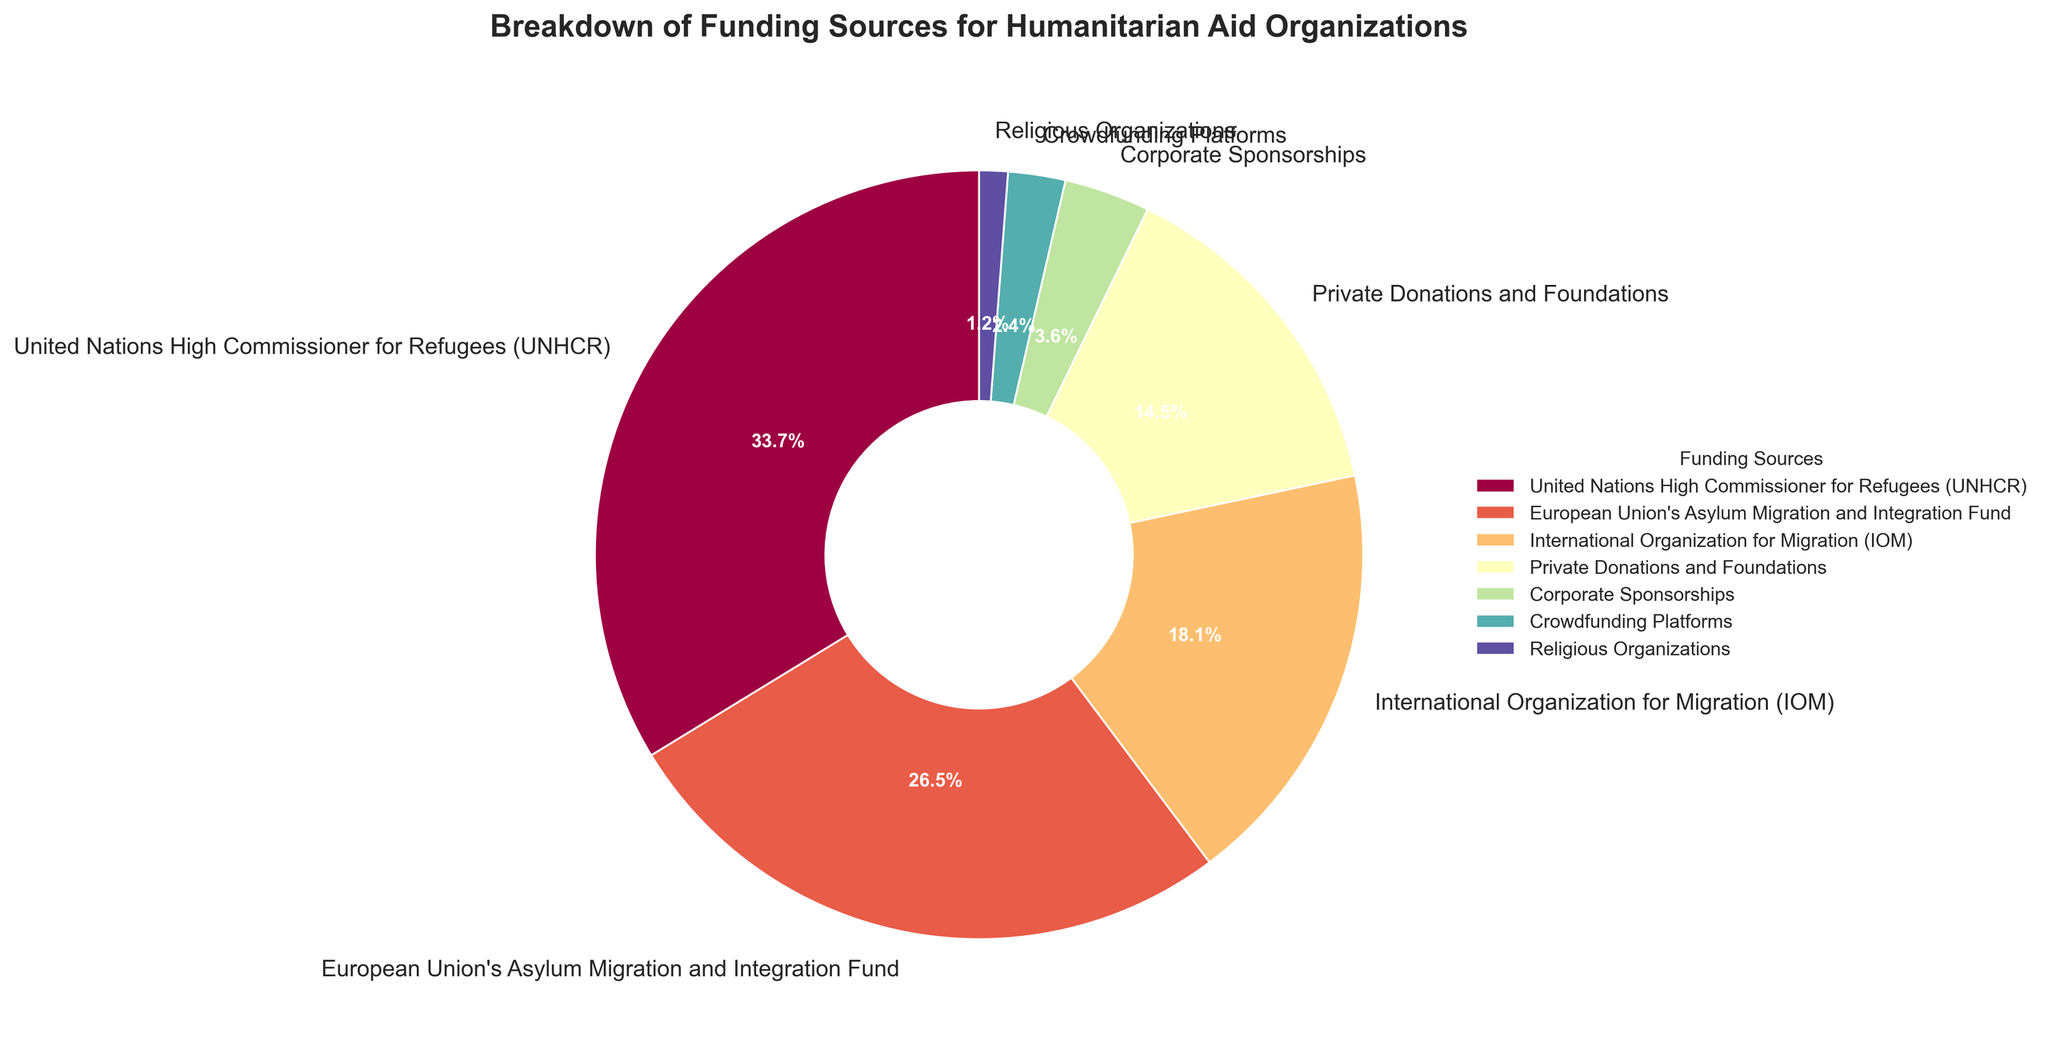Which funding source contributes the largest percentage? Look at the pie chart and identify the segment representing the largest portion. The UNHCR segment is the largest.
Answer: United Nations High Commissioner for Refugees (UNHCR) Which two funding sources together contribute more than 40% of the total funding? Identify pairs of segments in the pie chart whose combined percentages exceed 40%. The pairs of 'UNHCR' and 'European Union's Asylum Migration and Integration Fund' contribute a combined total of 28% + 22% = 50%.
Answer: United Nations High Commissioner for Refugees (UNHCR) and European Union's Asylum Migration and Integration Fund How much larger is the contribution of corporate sponsorships compared to crowdfunding platforms? Check the pie chart for the percentages of corporate sponsorships and crowdfunding platforms. Subtract the smaller percentage from the larger one: 3% - 2% = 1%.
Answer: 1% Which funding source contributes the smallest percentage? Identify the smallest segment in the pie chart. The smallest segment is labeled as 'Religious Organizations.'
Answer: Religious Organizations What is the total contribution percentage of private donations, corporate sponsorships, and religious organizations? Add the percentages of the three funding sources: 12% (Private Donations) + 3% (Corporate Sponsorships) + 1% (Religious Organizations). The total is 12% + 3% + 1% = 16%.
Answer: 16% How does the contribution of the International Organization for Migration compare to private donations and foundations? Compare the segments for International Organization for Migration (IOM) and Private Donations and Foundations in the pie chart. IOM contributes 15%, and Private Donations and Foundations contribute 12%, so IOM contributes 3% more.
Answer: IOM contributions are 3% higher Which funding sources combined contribute less than 10% of the total funding? Identify and sum segments that, when combined, are less than 10%. The segments for Corporate Sponsorships (3%), Crowdfunding Platforms (2%), and Religious Organizations (1%) total 3% + 2% + 1% = 6%.
Answer: Corporate Sponsorships, Crowdfunding Platforms, and Religious Organizations Which funding source(s) contribute(s) more than 20% of the total funding? Identify segments in the pie chart that exceed 20%. Both UNHCR and European Union's Asylum Migration and Integration Fund exceed this threshold with 28% and 22%, respectively.
Answer: United Nations High Commissioner for Refugees (UNHCR) and European Union's Asylum Migration and Integration Fund 